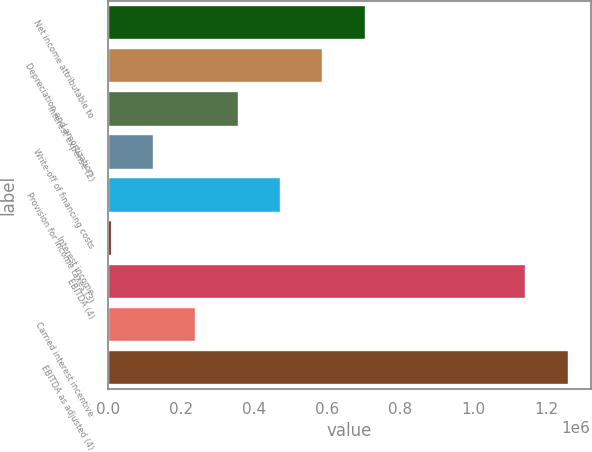<chart> <loc_0><loc_0><loc_500><loc_500><bar_chart><fcel>Net income attributable to<fcel>Depreciation and amortization<fcel>Interest expense (2)<fcel>Write-off of financing costs<fcel>Provision for income taxes (3)<fcel>Interest income<fcel>EBITDA (4)<fcel>Carried interest incentive<fcel>EBITDA as adjusted (4)<nl><fcel>702168<fcel>586179<fcel>354201<fcel>122222<fcel>470190<fcel>6233<fcel>1.14225e+06<fcel>238211<fcel>1.25824e+06<nl></chart> 